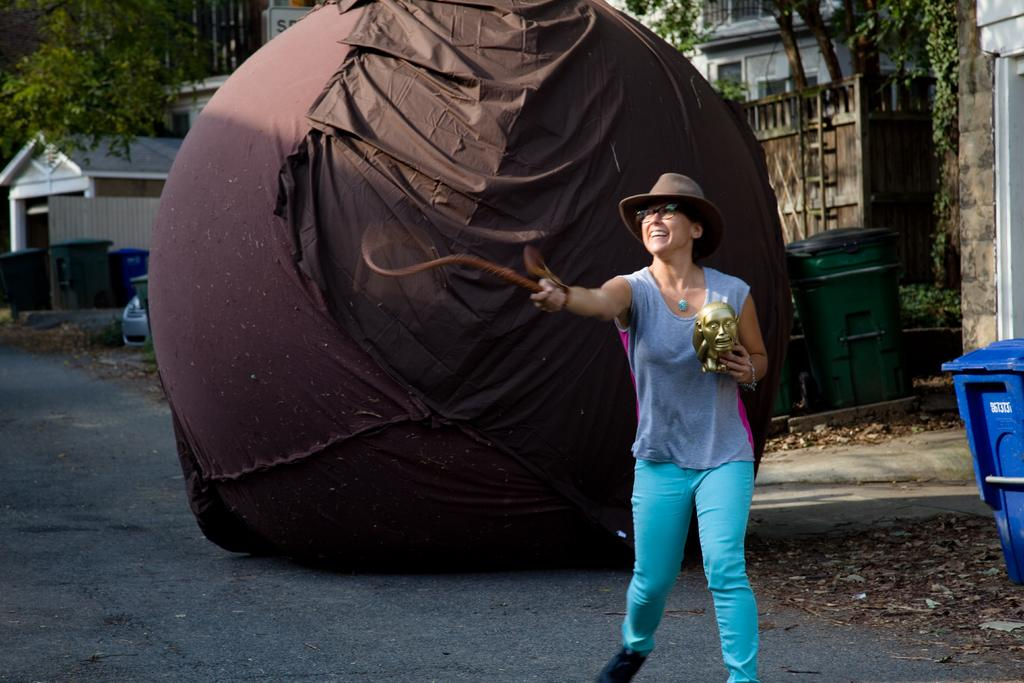What is the woman holding in her hands in the image? The woman is holding a sculpture with one hand and a rope with another hand. What can be seen in the background of the image? There are bins, a shed, a building, trees, a ladder, and a huge object in the background of the image. What type of fact can be found in the harbor in the image? There is no harbor present in the image, so it is not possible to find any facts there. 